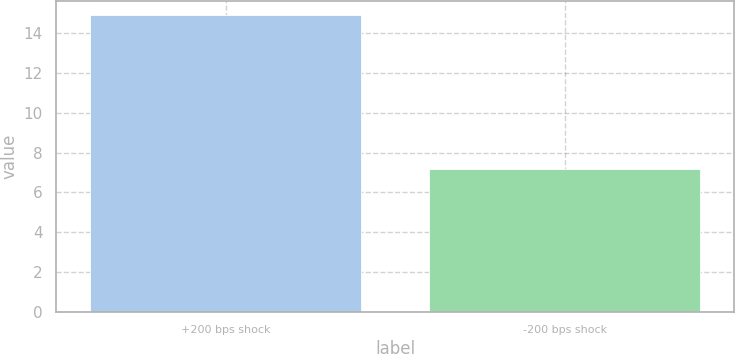Convert chart. <chart><loc_0><loc_0><loc_500><loc_500><bar_chart><fcel>+200 bps shock<fcel>-200 bps shock<nl><fcel>14.9<fcel>7.2<nl></chart> 